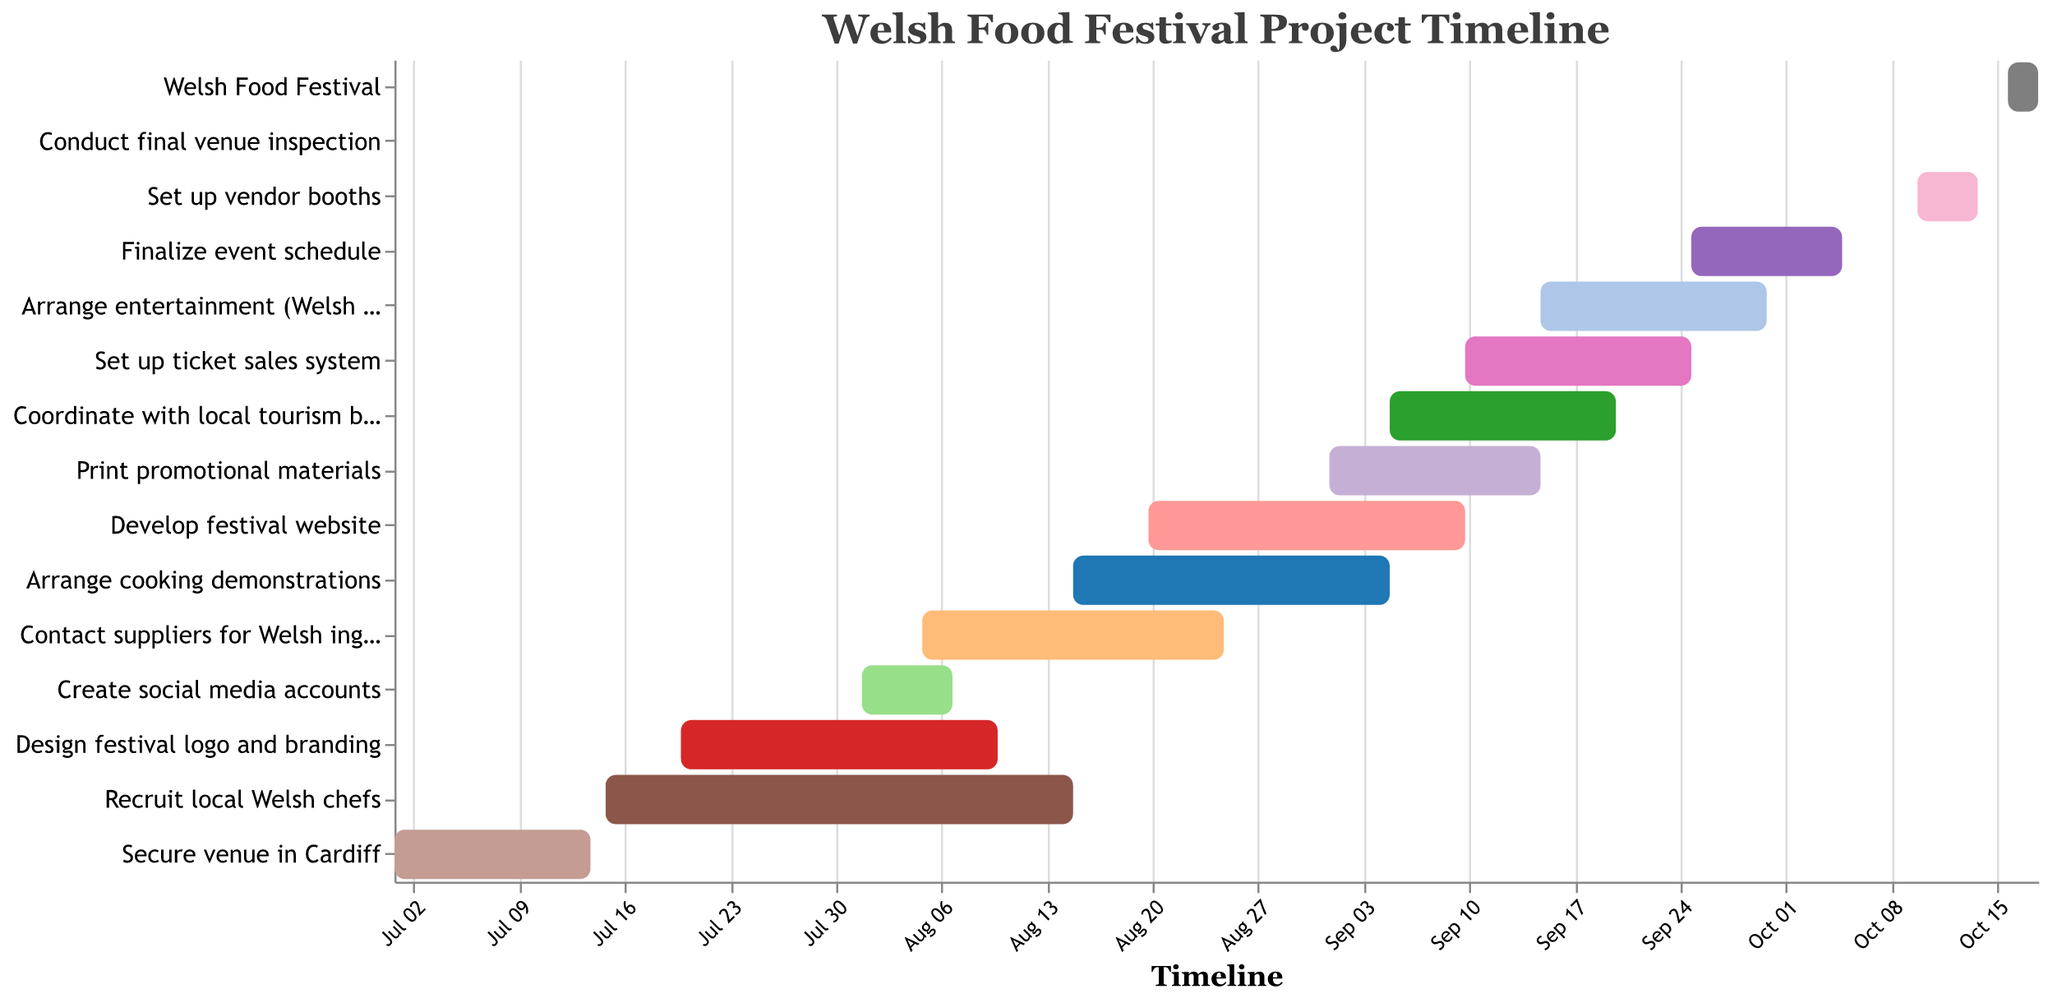How long does securing the venue in Cardiff take? The task "Secure venue in Cardiff" has a duration listed in the chart. By looking at the Gantt Chart, one can see the "Duration (days)" is 14.
Answer: 14 days When does the development of the festival website start and end? By referring to the "Develop festival website" task in the Gantt Chart, the "Start Date" is indicated as "2023-08-20" and the "End Date" is "2023-09-10".
Answer: 2023-08-20 to 2023-09-10 Which task has the longest duration, and how many days does it last? To determine the longest task duration, we scan the "Duration" values for all tasks in the Gantt Chart. The "Recruit local Welsh chefs" task has the highest duration of 32 days.
Answer: Recruit local Welsh chefs, 32 days How many tasks have a duration of less than 10 days? By examining the "Duration" values for each task in the chart, the tasks with durations less than 10 are "Create social media accounts" (7 days), "Set up vendor booths" (5 days), and "Conduct final venue inspection" (1 day), totaling to 3 tasks.
Answer: 3 tasks Which two tasks overlap in their start and end dates between August 5 and August 25, inclusive? By analyzing tasks within the date range from August 5 to August 25, the "Contact suppliers for Welsh ingredients" (2023-08-05 to 2023-08-25) and "Create social media accounts" (2023-08-01 to 2023-08-07) overlap on August 5 to 7. The "Arrange cooking demonstrations" (2023-08-15 to 2023-09-05) starts during this period as well, but doesn't overlap completely.
Answer: Contact suppliers for Welsh ingredients and Create social media accounts Which tasks need to be completed before starting to arrange entertainment? "Arrange entertainment" starts on "2023-09-15". By reviewing tasks that conclude by this date, "Secure venue in Cardiff", "Recruit local Welsh chefs", "Design festival logo and branding", "Create social media accounts", "Contact suppliers for Welsh ingredients", "Arrange cooking demonstrations", "Develop festival website", "Print promotional materials", "Coordinate with local tourism board", and "Set up ticket sales system" must all be completed.
Answer: Secure venue in Cardiff, Recruit local Welsh chefs, Design festival logo and branding, Create social media accounts, Contact suppliers for Welsh ingredients, Arrange cooking demonstrations, Develop festival website, Print promotional materials, Coordinate with local tourism board, Set up ticket sales system Which task has the shortest duration, and what is its duration? Reviewing the duration values in the chart, the "Conduct final venue inspection" task has the shortest duration of just 1 day.
Answer: Conduct final venue inspection, 1 day Which task concludes the latest before the actual Welsh Food Festival starts? The "Finalize event schedule" task ends on "2023-10-05", which is the latest completion before the "Welsh Food Festival" starts on "2023-10-16".
Answer: Finalize event schedule How many tasks are scheduled in the month of September? Reviewing the start and end dates in the Gantt Chart for the month of September, we find "Print promotional materials", "Coordinate with local tourism board", "Set up ticket sales system", "Arrange entertainment (Welsh music)" and "Finalize event schedule", totaling to 5 tasks.
Answer: 5 tasks 